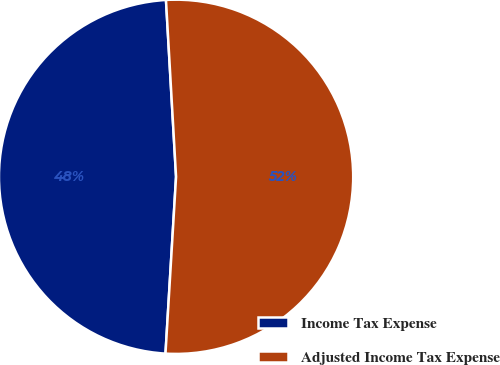Convert chart. <chart><loc_0><loc_0><loc_500><loc_500><pie_chart><fcel>Income Tax Expense<fcel>Adjusted Income Tax Expense<nl><fcel>48.14%<fcel>51.86%<nl></chart> 